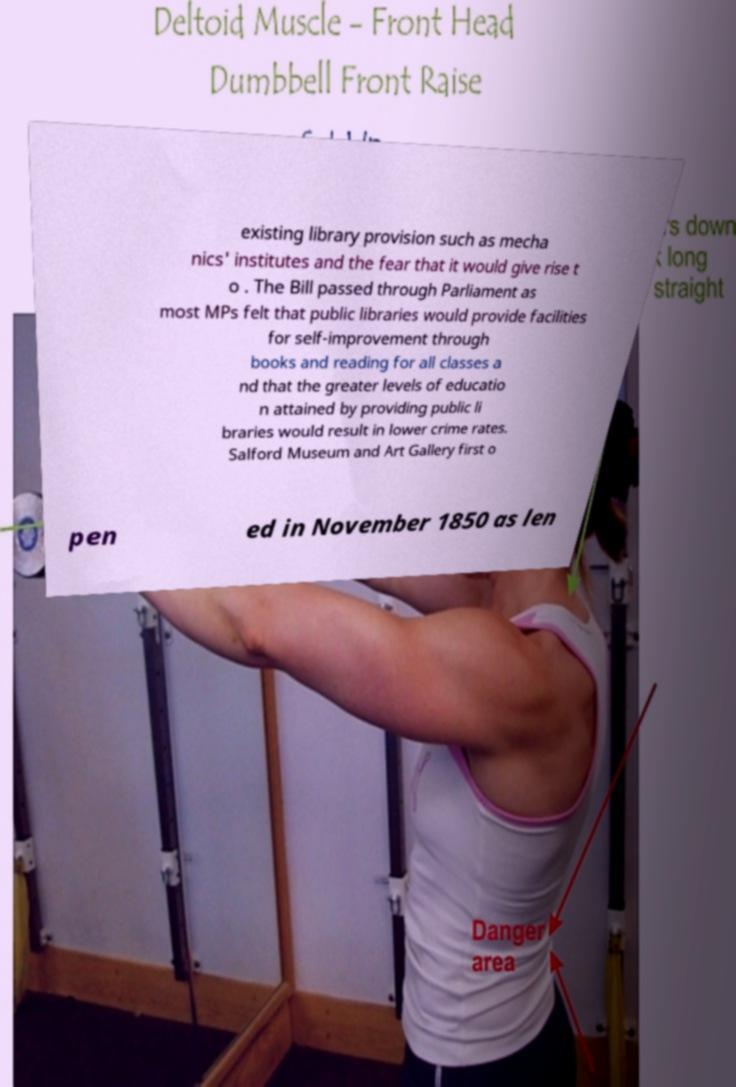Could you extract and type out the text from this image? existing library provision such as mecha nics' institutes and the fear that it would give rise t o . The Bill passed through Parliament as most MPs felt that public libraries would provide facilities for self-improvement through books and reading for all classes a nd that the greater levels of educatio n attained by providing public li braries would result in lower crime rates. Salford Museum and Art Gallery first o pen ed in November 1850 as len 